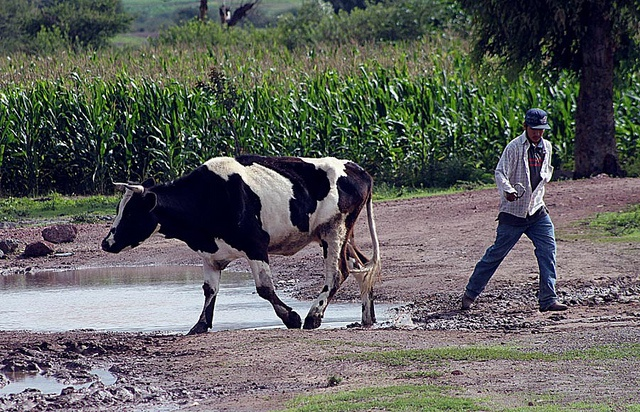Describe the objects in this image and their specific colors. I can see cow in gray, black, darkgray, and lightgray tones, people in gray, black, navy, and darkgray tones, and bird in gray, lightgray, and darkgray tones in this image. 